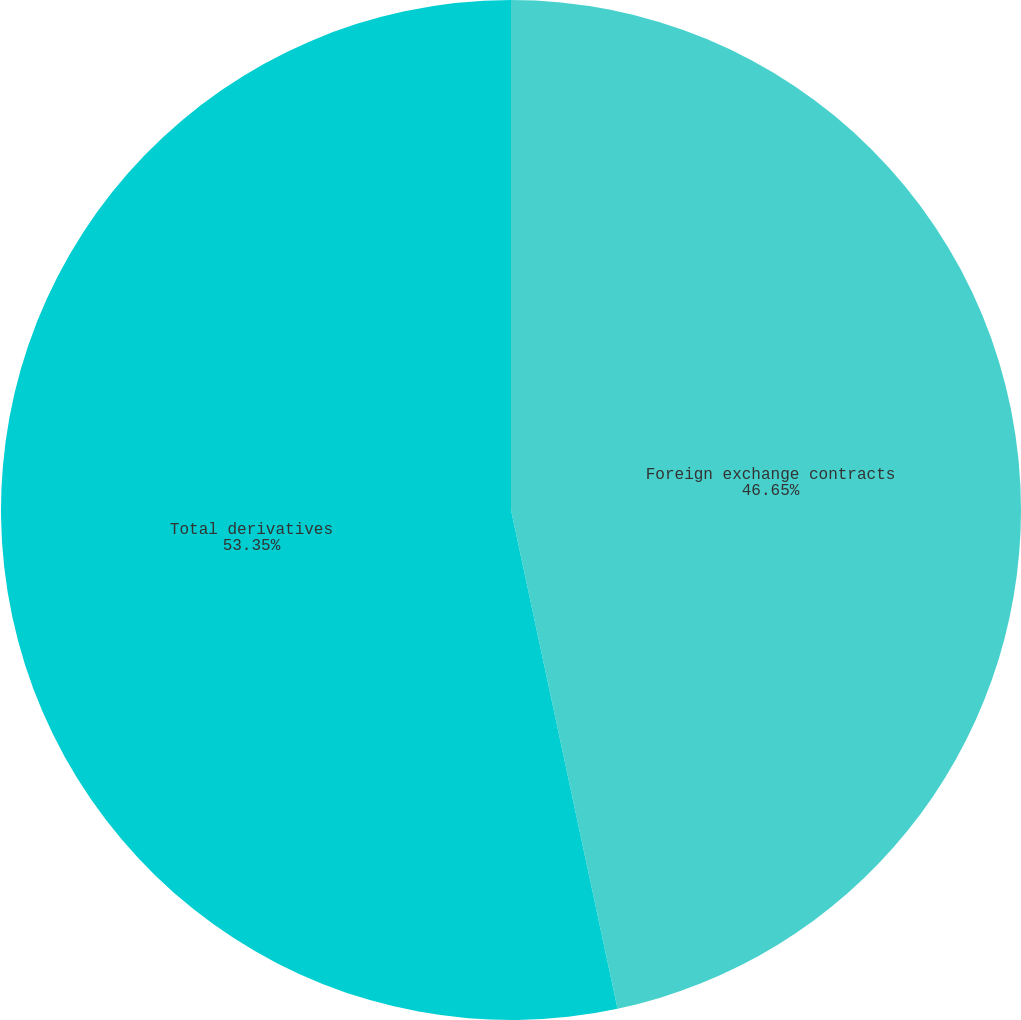Convert chart. <chart><loc_0><loc_0><loc_500><loc_500><pie_chart><fcel>Foreign exchange contracts<fcel>Total derivatives<nl><fcel>46.65%<fcel>53.35%<nl></chart> 